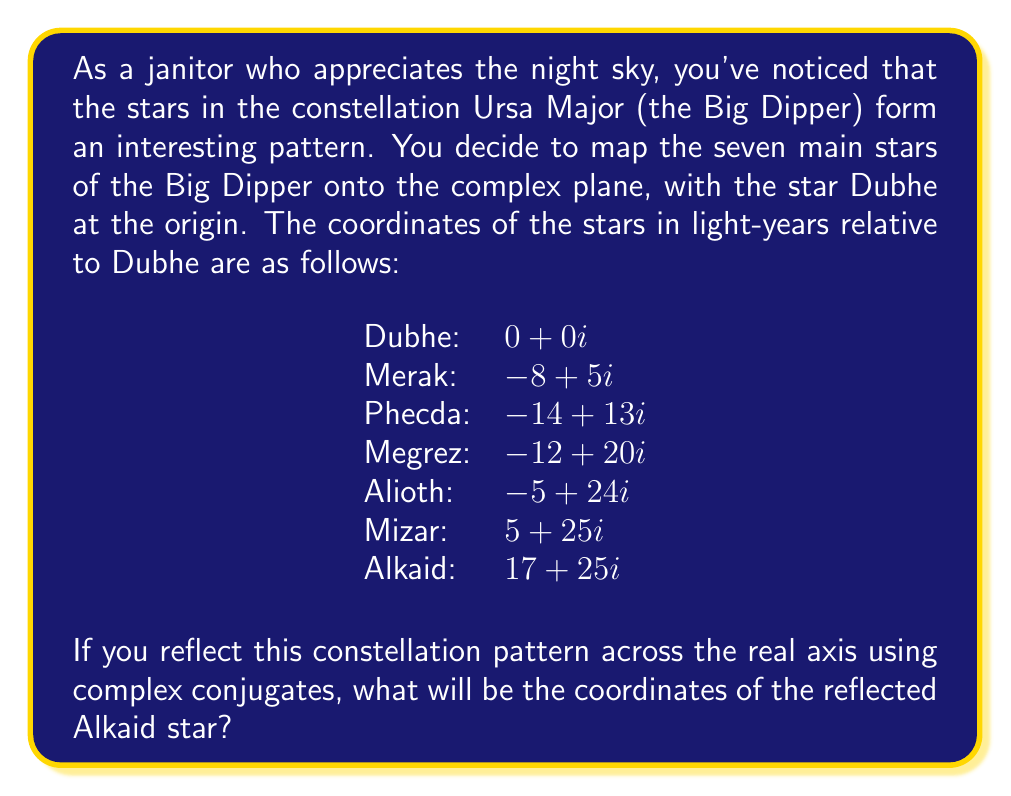Can you answer this question? Let's approach this step-by-step:

1) First, recall that the complex conjugate of a complex number $a + bi$ is $a - bi$. This operation reflects a point across the real axis.

2) The original coordinates of Alkaid are $17 + 25i$.

3) To find the complex conjugate, we keep the real part the same and negate the imaginary part:

   $$(17 + 25i)^* = 17 - 25i$$

4) This means that the reflected Alkaid will be at the point $(17, -25)$ in the complex plane.

5) To verify, let's visualize this:

   [asy]
   import graph;
   size(200);
   
   dot((0,0),red);
   dot((-8,5),red);
   dot((-14,13),red);
   dot((-12,20),red);
   dot((-5,24),red);
   dot((5,25),red);
   dot((17,25),red);
   
   dot((17,-25),blue);
   
   label("Dubhe",(0,0),SW);
   label("Merak",(-8,5),SW);
   label("Phecda",(-14,13),SW);
   label("Megrez",(-12,20),SW);
   label("Alioth",(-5,24),NW);
   label("Mizar",(5,25),NW);
   label("Alkaid",(17,25),NE);
   label("Reflected Alkaid",(17,-25),SE);
   
   draw((0,0)--(-8,5)--(-14,13)--(-12,20)--(-5,24)--(5,25)--(17,25),red);
   draw((17,25)--(17,-25),dashed);
   
   xaxis(Label("Real"),Arrow);
   yaxis(Label("Imaginary"),Arrow);
   [/asy]

This diagram shows the original constellation in red and the reflected Alkaid in blue.
Answer: The coordinates of the reflected Alkaid star are $17 - 25i$ or $(17, -25)$ in the complex plane. 